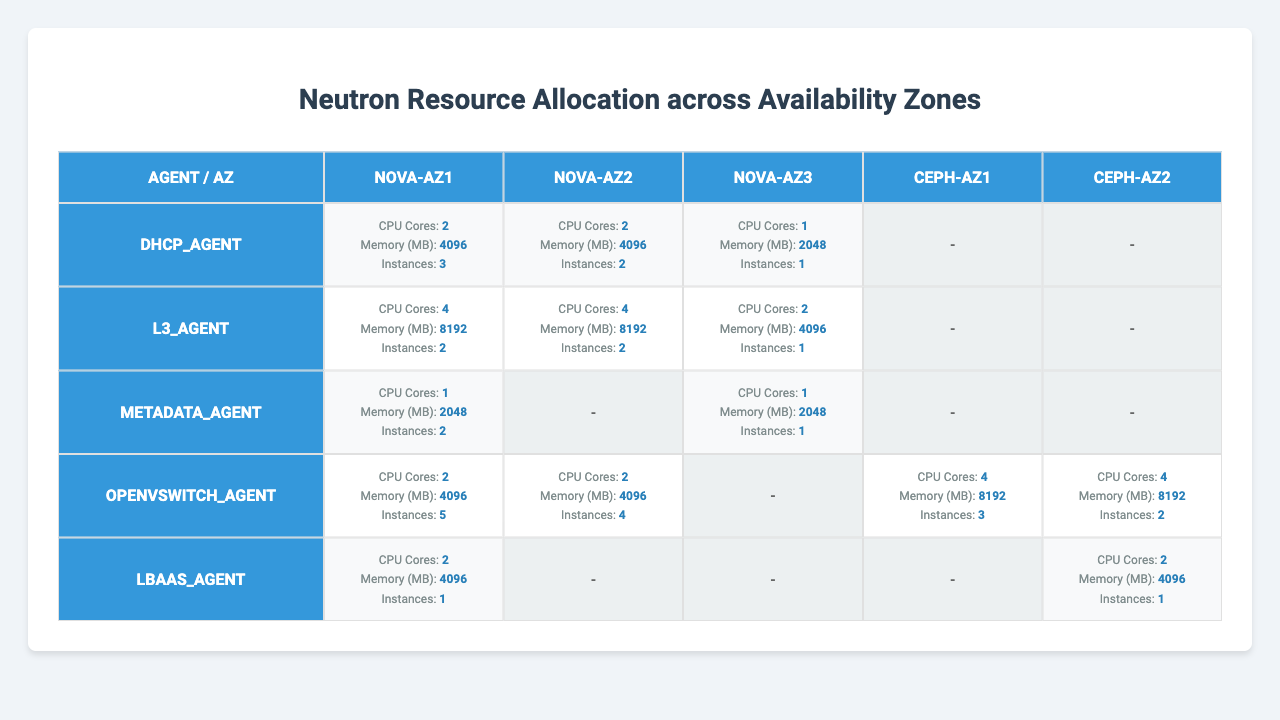What is the total number of CPU cores allocated for the l3_agent across all availability zones? From the table, the l3_agent has 4 CPU cores in both nova-az1 and nova-az2, totaling 8. For nova-az3, it has 2 CPU cores. Therefore, summing these values: 4 (nova-az1) + 4 (nova-az2) + 2 (nova-az3) = 10.
Answer: 10 Which availability zone has the highest memory allocation for the openvswitch_agent? In the table, the openvswitch_agent has the highest memory allocation in ceph-az1 and ceph-az2, both with 8192 MB. Therefore, these are the maximum values compared to others where it has 4096 MB.
Answer: ceph-az1 and ceph-az2 Is there any availability zone where the metadata_agent is not allocated? Looking at the table, the metadata_agent is only allocated in nova-az1 and nova-az3, and there are no entries for it in nova-az2, ceph-az1, and ceph-az2. Therefore, those zones do not have the metadata_agent allocated.
Answer: Yes What is the average number of instances for the dhcp_agent across the availability zones? The instances for dhcp_agent are as follows: 3 (nova-az1), 2 (nova-az2), and 1 (nova-az3). Sum of instances is 3 + 2 + 1 = 6. Dividing this by the number of available zones that have allocated dhcp_agent (3), yields an average of 6 / 3 = 2.
Answer: 2 Which agent is allocated the least memory overall, and in which availability zone is it found? Scanning through the table, the metadata_agent has the least memory allocation of 2048 MB in both nova-az1 and nova-az3. Therefore, the answer is in those respective zones.
Answer: metadata_agent in nova-az1 and nova-az3 How many total instances are allocated for the openvswitch_agent in ceph availability zones? The table shows that the openvswitch_agent has 3 instances in ceph-az1 and 2 instances in ceph-az2. Thus, the total number is 3 + 2 = 5 instances across both ceph availability zones.
Answer: 5 For which agent is the total memory allocation across all zones greater than 10,000 MB? By checking the total memory for each agent: the l3_agent has 8192 MB (nova-az1) + 8192 MB (nova-az2) + 4096 MB (nova-az3) = 20480 MB, which is over 10,000 MB. Therefore, only the l3_agent surpasses this threshold.
Answer: l3_agent Does the total number of instances for lbaas_agent exceed that of the metadata_agent across all availability zones? Adding the instances: lbaas_agent has 1 (nova-az1) + 1 (ceph-az2) = 2 instances, while metadata_agent has 2 (nova-az1) + 1 (nova-az3) = 3 instances. Since 2 < 3, lbaas_agent's instances do not exceed those of metadata_agent.
Answer: No What is the maximum number of instances allocated to the dhcp_agent in any single availability zone? Looking at the instances allocated for dhcp_agent, 3 instances are allocated in nova-az1, 2 in nova-az2, and 1 in nova-az3. The maximum number is thus 3 in nova-az1.
Answer: 3 Is the overall resource allocation for agents in ceph-az1 greater than in nova-az3 for CPU cores? For ceph-az1, the only allocated agent is openvswitch_agent with 4 CPU cores. In nova-az3, the total is 1 (dhcp_agent) + 2 (l3_agent) + 1 (metadata_agent) = 4 CPU cores. Thus the allocations are equal.
Answer: No 